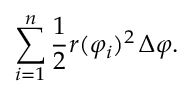Convert formula to latex. <formula><loc_0><loc_0><loc_500><loc_500>\sum _ { i = 1 } ^ { n } { \frac { 1 } { 2 } } r ( \varphi _ { i } ) ^ { 2 } \, \Delta \varphi .</formula> 